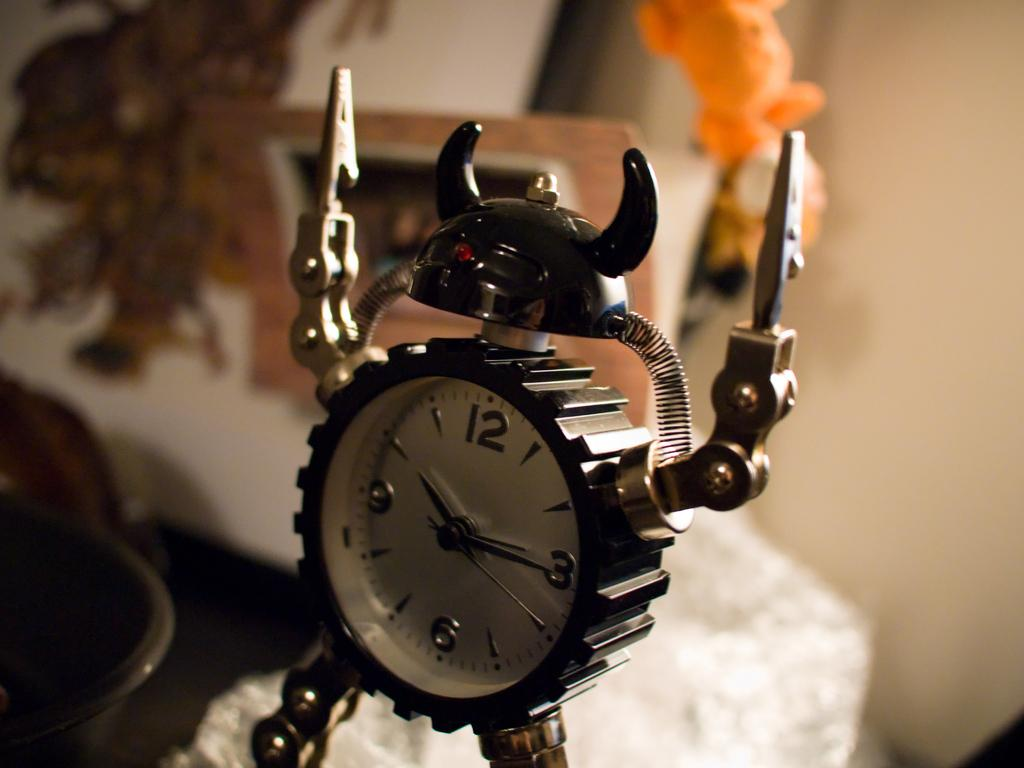<image>
Render a clear and concise summary of the photo. A robot alarm clock shows the time as 10:15. 